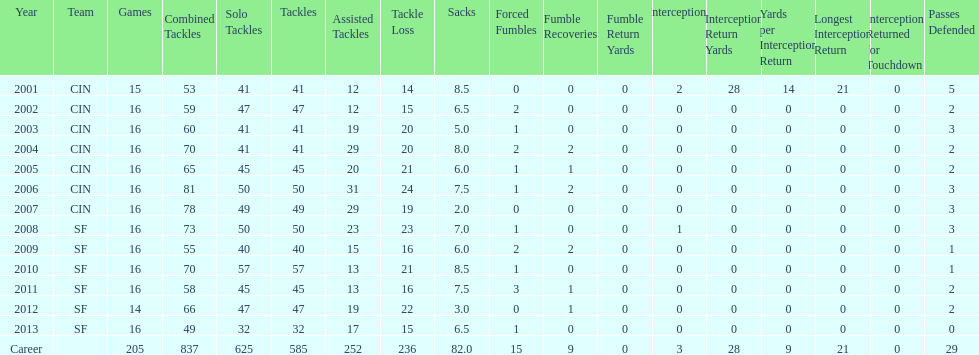How many years did he play where he did not recover a fumble? 7. 